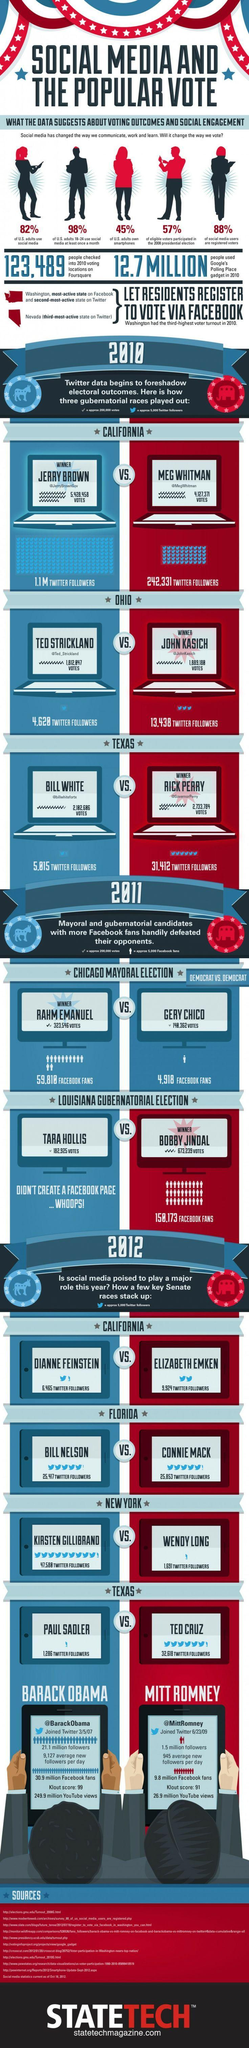Among those listed who doesn't have a Facebook page?
Answer the question with a short phrase. TARA HOLLIS What is the Twitter handle of the winner in California? @JerryBrownGov How many Twitter followers does the Ohio winner have? 13,438 Who had more Twitter followers in Florida? CONNIE MACK Who has a higher Klout score- Barack Obama or Mitt Romney? Barack Obama How many sources are listed at the bottom? 10 